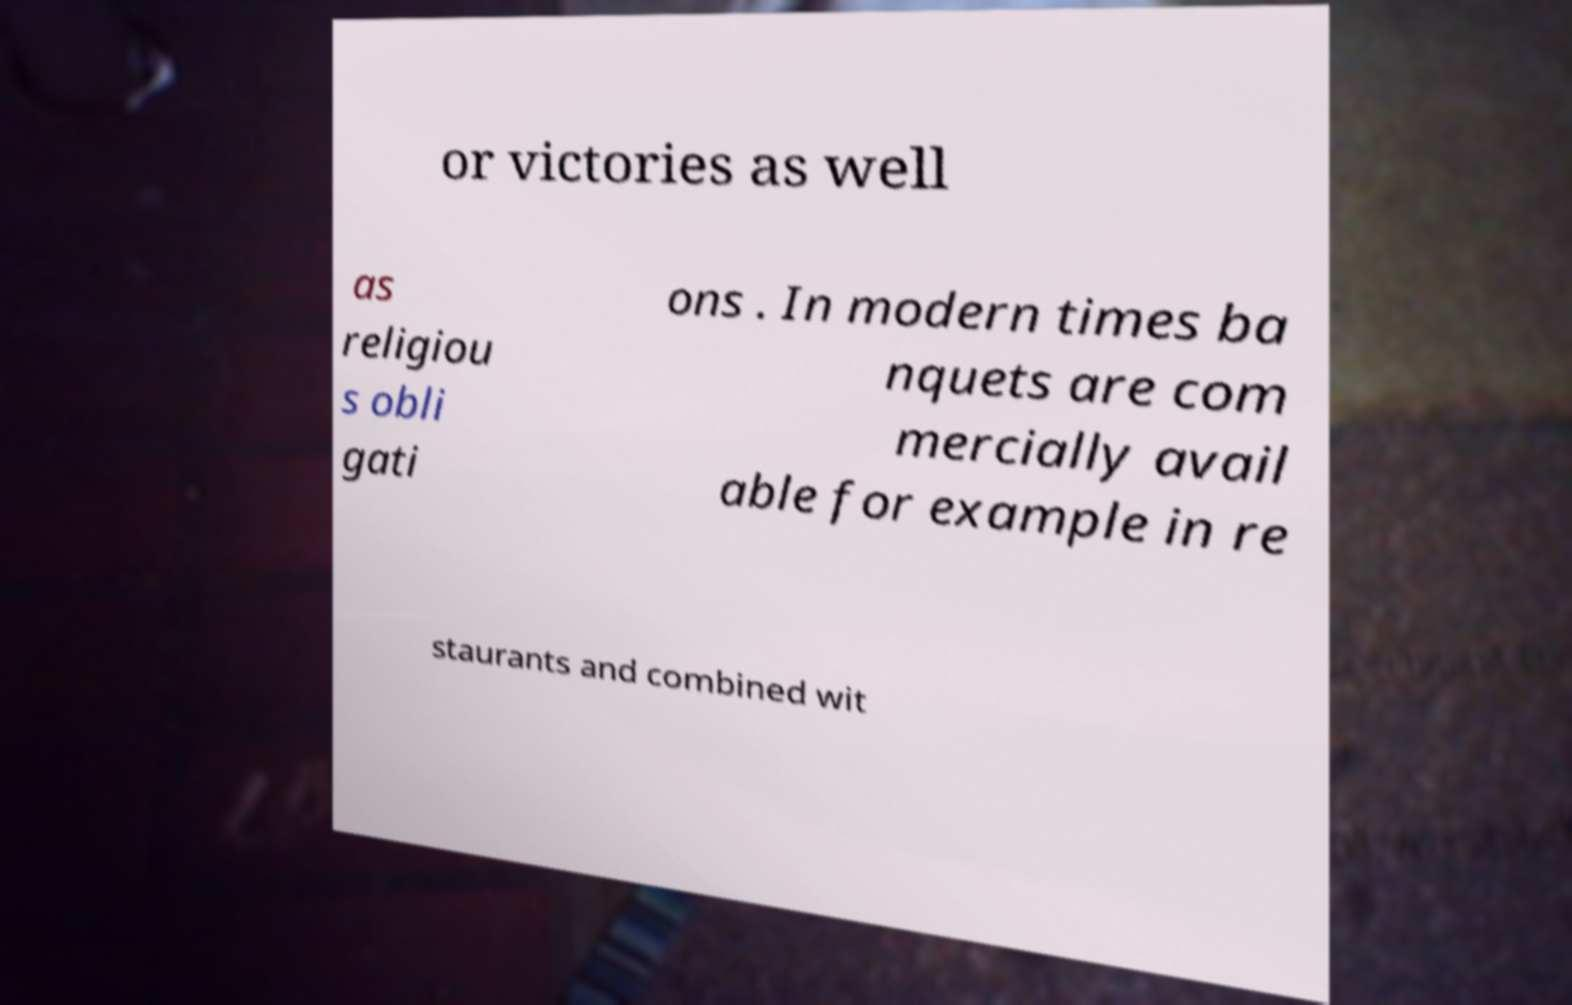Could you assist in decoding the text presented in this image and type it out clearly? or victories as well as religiou s obli gati ons . In modern times ba nquets are com mercially avail able for example in re staurants and combined wit 